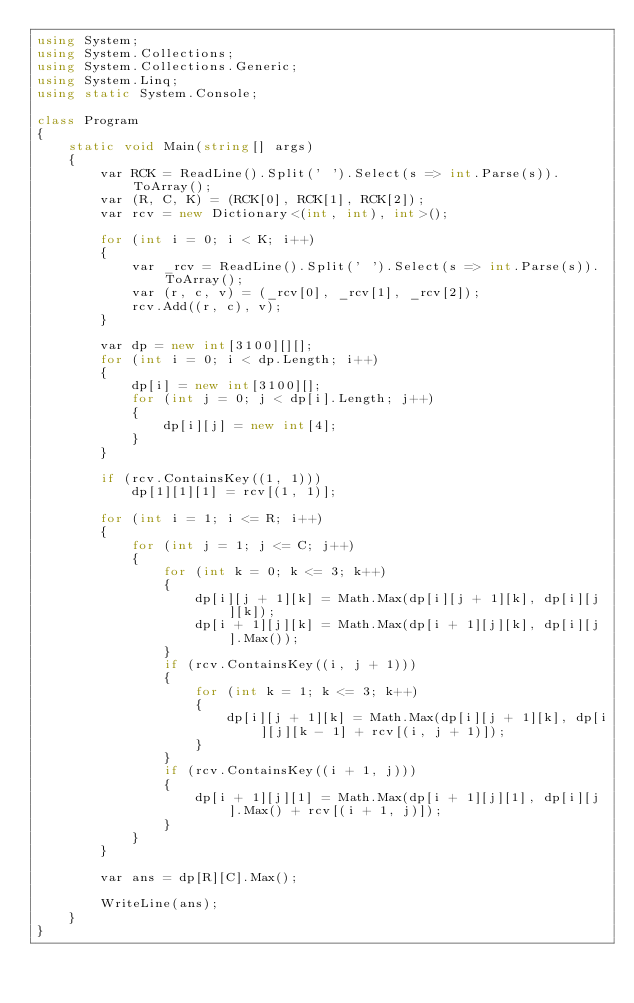<code> <loc_0><loc_0><loc_500><loc_500><_C#_>using System;
using System.Collections;
using System.Collections.Generic;
using System.Linq;
using static System.Console;

class Program
{
    static void Main(string[] args)
    {
        var RCK = ReadLine().Split(' ').Select(s => int.Parse(s)).ToArray();
        var (R, C, K) = (RCK[0], RCK[1], RCK[2]);
        var rcv = new Dictionary<(int, int), int>();

        for (int i = 0; i < K; i++)
        {
            var _rcv = ReadLine().Split(' ').Select(s => int.Parse(s)).ToArray();
            var (r, c, v) = (_rcv[0], _rcv[1], _rcv[2]);
            rcv.Add((r, c), v);
        }

        var dp = new int[3100][][];
        for (int i = 0; i < dp.Length; i++)
        {
            dp[i] = new int[3100][];
            for (int j = 0; j < dp[i].Length; j++)
            {
                dp[i][j] = new int[4];
            }
        }

        if (rcv.ContainsKey((1, 1)))
            dp[1][1][1] = rcv[(1, 1)];

        for (int i = 1; i <= R; i++)
        {
            for (int j = 1; j <= C; j++)
            {
                for (int k = 0; k <= 3; k++)
                {
                    dp[i][j + 1][k] = Math.Max(dp[i][j + 1][k], dp[i][j][k]);
                    dp[i + 1][j][k] = Math.Max(dp[i + 1][j][k], dp[i][j].Max());
                }
                if (rcv.ContainsKey((i, j + 1)))
                {
                    for (int k = 1; k <= 3; k++)
                    {
                        dp[i][j + 1][k] = Math.Max(dp[i][j + 1][k], dp[i][j][k - 1] + rcv[(i, j + 1)]);
                    }
                }
                if (rcv.ContainsKey((i + 1, j)))
                {
                    dp[i + 1][j][1] = Math.Max(dp[i + 1][j][1], dp[i][j].Max() + rcv[(i + 1, j)]);
                }
            }
        }

        var ans = dp[R][C].Max();

        WriteLine(ans);
    }
}
</code> 